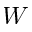Convert formula to latex. <formula><loc_0><loc_0><loc_500><loc_500>W</formula> 